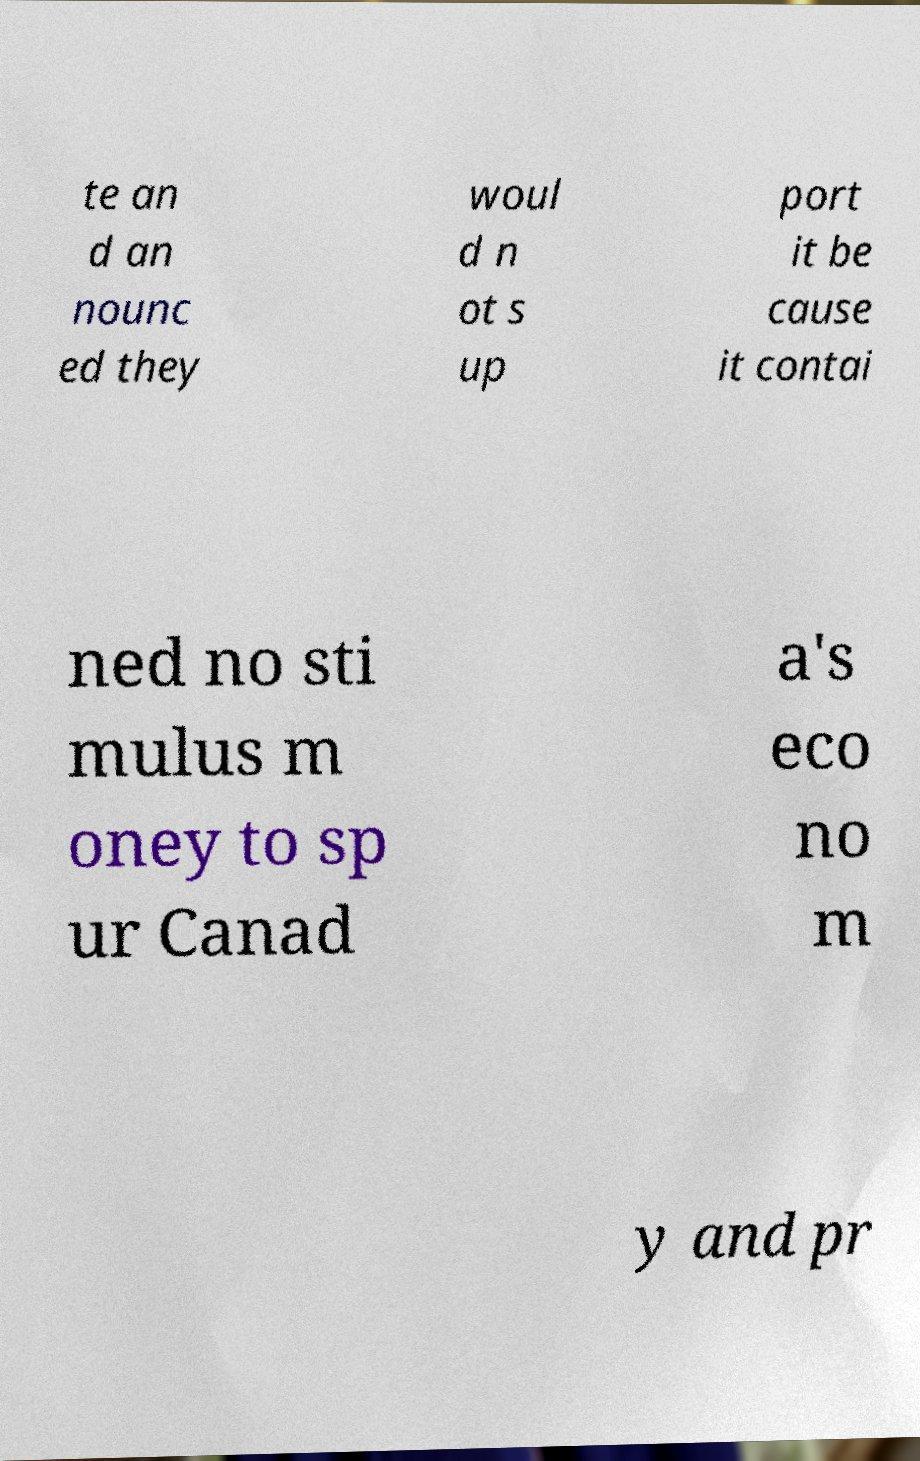Please identify and transcribe the text found in this image. te an d an nounc ed they woul d n ot s up port it be cause it contai ned no sti mulus m oney to sp ur Canad a's eco no m y and pr 